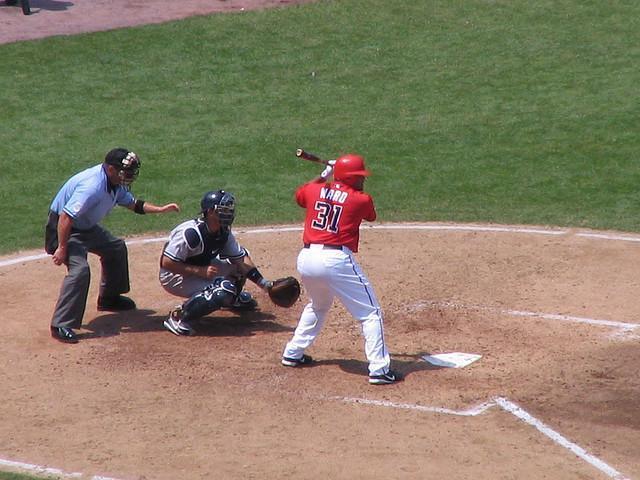How many people can you see?
Give a very brief answer. 3. How many legs of the elephant are shown?
Give a very brief answer. 0. 